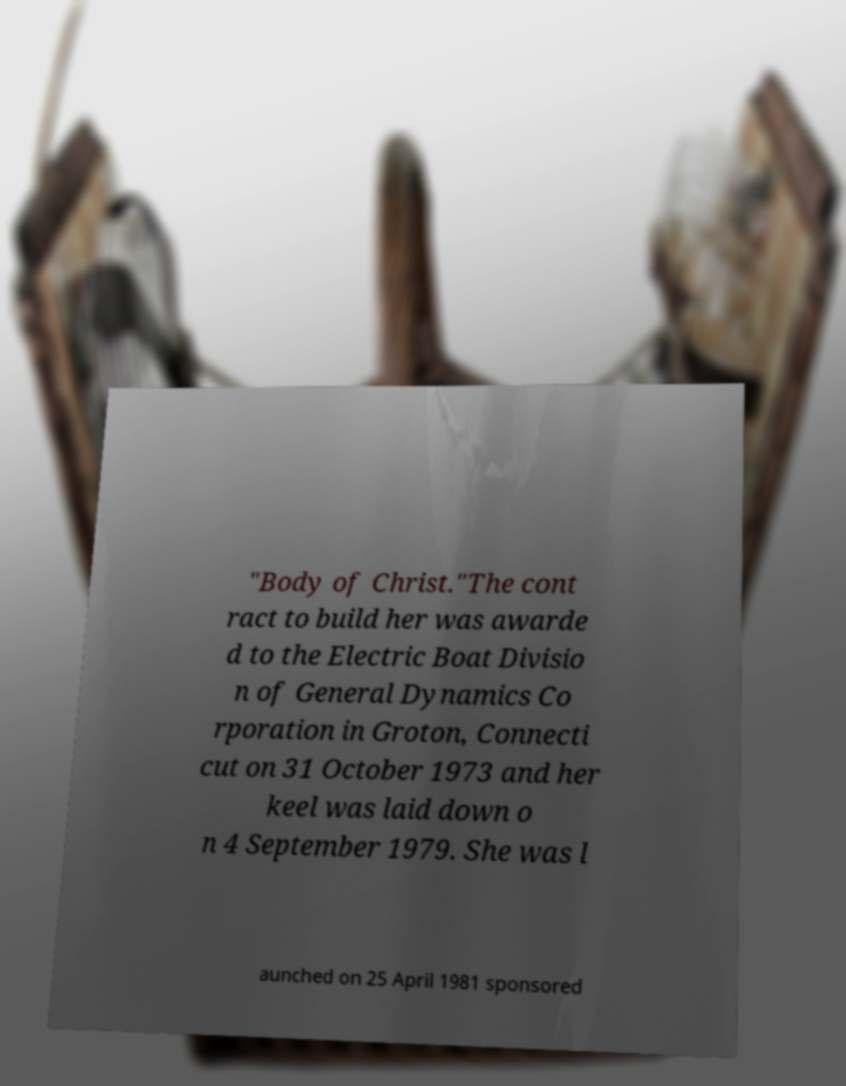Can you accurately transcribe the text from the provided image for me? "Body of Christ."The cont ract to build her was awarde d to the Electric Boat Divisio n of General Dynamics Co rporation in Groton, Connecti cut on 31 October 1973 and her keel was laid down o n 4 September 1979. She was l aunched on 25 April 1981 sponsored 